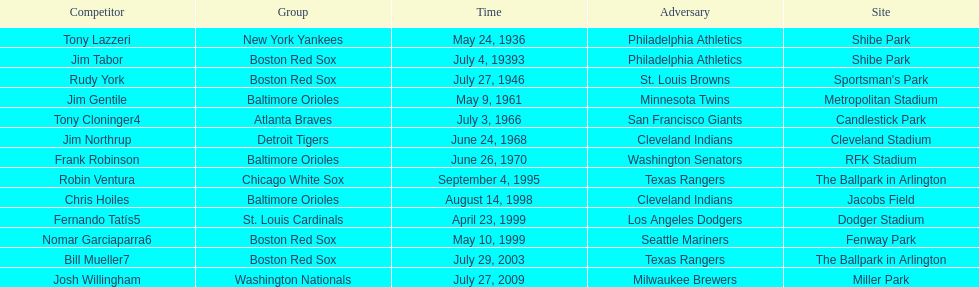Could you parse the entire table as a dict? {'header': ['Competitor', 'Group', 'Time', 'Adversary', 'Site'], 'rows': [['Tony Lazzeri', 'New York Yankees', 'May 24, 1936', 'Philadelphia Athletics', 'Shibe Park'], ['Jim Tabor', 'Boston Red Sox', 'July 4, 19393', 'Philadelphia Athletics', 'Shibe Park'], ['Rudy York', 'Boston Red Sox', 'July 27, 1946', 'St. Louis Browns', "Sportsman's Park"], ['Jim Gentile', 'Baltimore Orioles', 'May 9, 1961', 'Minnesota Twins', 'Metropolitan Stadium'], ['Tony Cloninger4', 'Atlanta Braves', 'July 3, 1966', 'San Francisco Giants', 'Candlestick Park'], ['Jim Northrup', 'Detroit Tigers', 'June 24, 1968', 'Cleveland Indians', 'Cleveland Stadium'], ['Frank Robinson', 'Baltimore Orioles', 'June 26, 1970', 'Washington Senators', 'RFK Stadium'], ['Robin Ventura', 'Chicago White Sox', 'September 4, 1995', 'Texas Rangers', 'The Ballpark in Arlington'], ['Chris Hoiles', 'Baltimore Orioles', 'August 14, 1998', 'Cleveland Indians', 'Jacobs Field'], ['Fernando Tatís5', 'St. Louis Cardinals', 'April 23, 1999', 'Los Angeles Dodgers', 'Dodger Stadium'], ['Nomar Garciaparra6', 'Boston Red Sox', 'May 10, 1999', 'Seattle Mariners', 'Fenway Park'], ['Bill Mueller7', 'Boston Red Sox', 'July 29, 2003', 'Texas Rangers', 'The Ballpark in Arlington'], ['Josh Willingham', 'Washington Nationals', 'July 27, 2009', 'Milwaukee Brewers', 'Miller Park']]} On what date did the detroit tigers play the cleveland indians? June 24, 1968. 